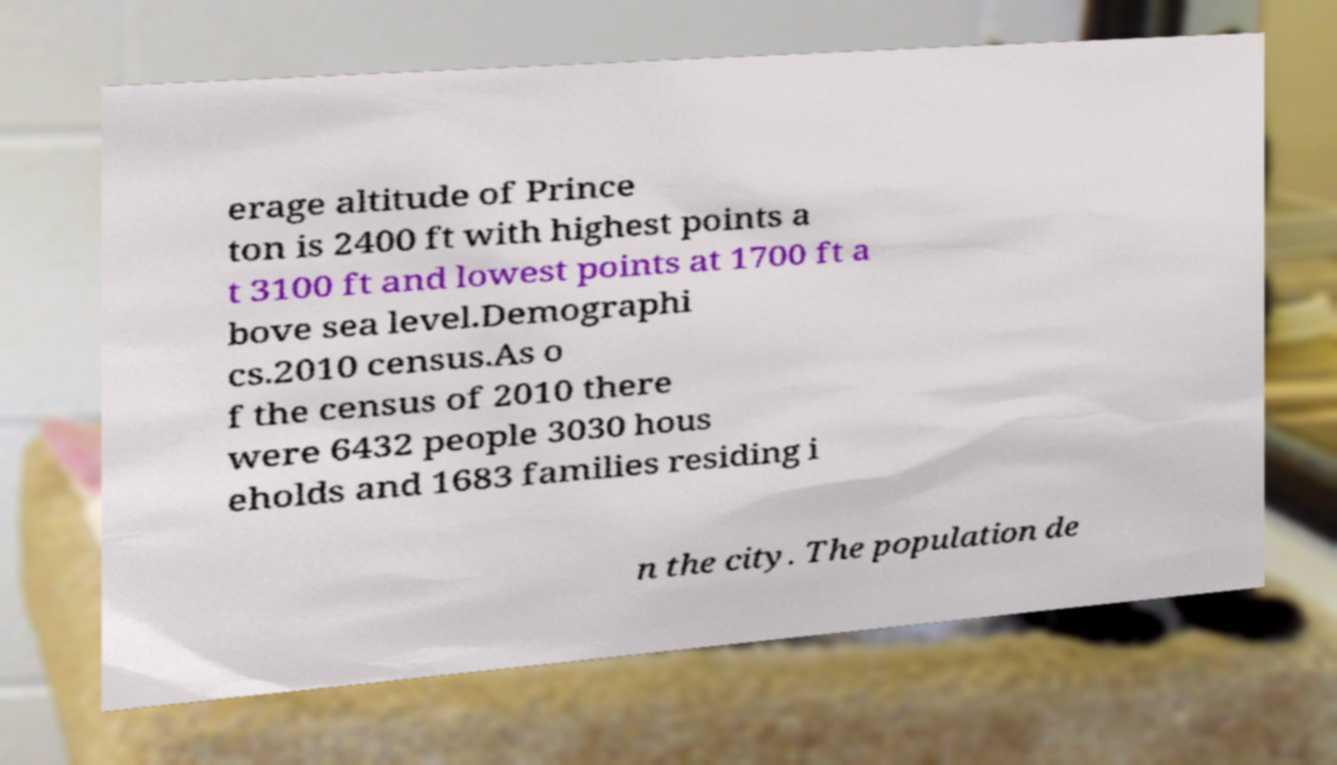Can you accurately transcribe the text from the provided image for me? erage altitude of Prince ton is 2400 ft with highest points a t 3100 ft and lowest points at 1700 ft a bove sea level.Demographi cs.2010 census.As o f the census of 2010 there were 6432 people 3030 hous eholds and 1683 families residing i n the city. The population de 